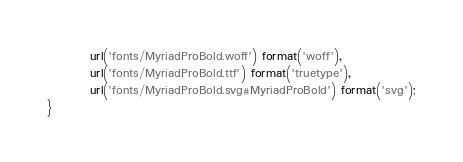<code> <loc_0><loc_0><loc_500><loc_500><_CSS_>         url('fonts/MyriadProBold.woff') format('woff'),
         url('fonts/MyriadProBold.ttf') format('truetype'),
         url('fonts/MyriadProBold.svg#MyriadProBold') format('svg');
}
</code> 